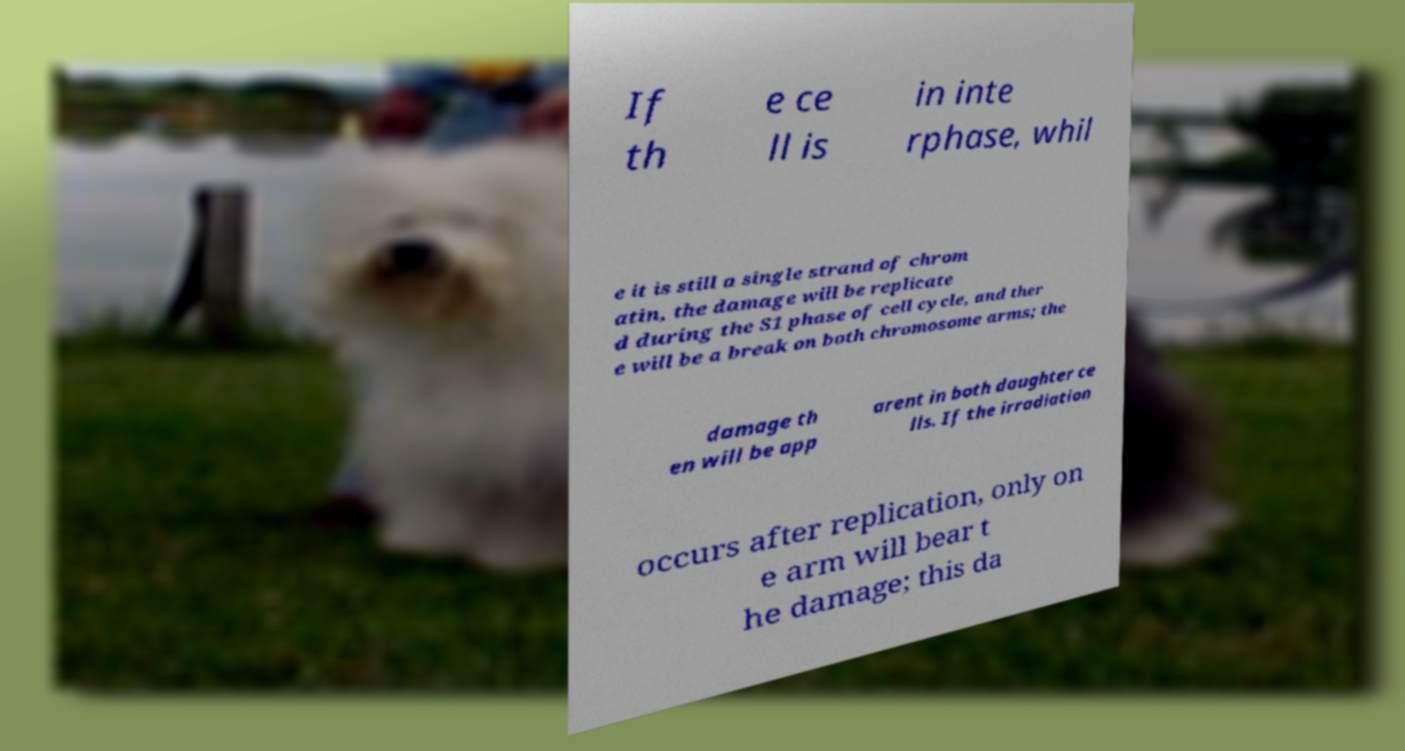Can you accurately transcribe the text from the provided image for me? If th e ce ll is in inte rphase, whil e it is still a single strand of chrom atin, the damage will be replicate d during the S1 phase of cell cycle, and ther e will be a break on both chromosome arms; the damage th en will be app arent in both daughter ce lls. If the irradiation occurs after replication, only on e arm will bear t he damage; this da 